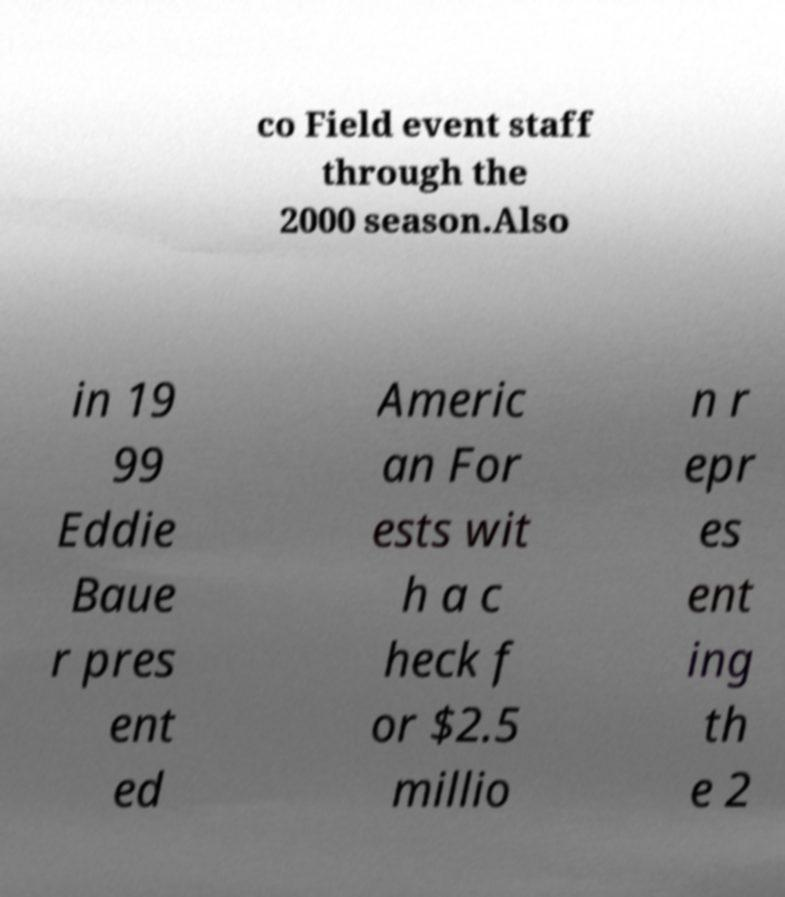Please read and relay the text visible in this image. What does it say? co Field event staff through the 2000 season.Also in 19 99 Eddie Baue r pres ent ed Americ an For ests wit h a c heck f or $2.5 millio n r epr es ent ing th e 2 